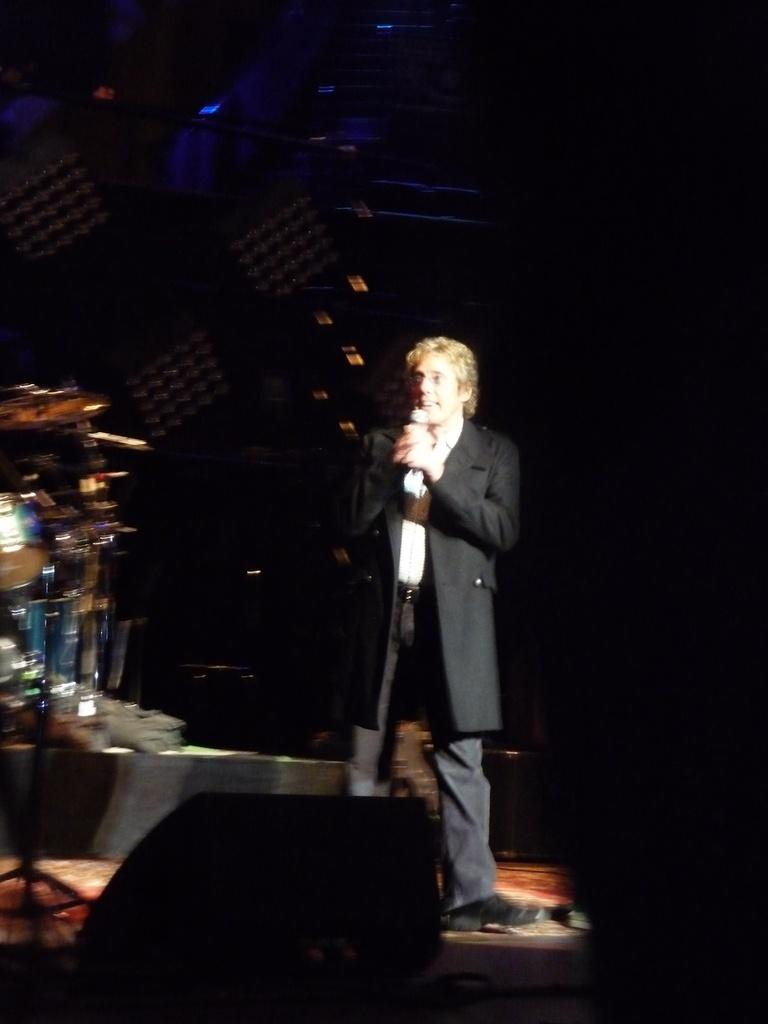What is the main feature of the image? There is a stage in the image. What is the person on the stage doing? One person is holding a microphone on the stage. What else can be seen on the stage? There are musical instruments on the left side of the stage. How would you describe the lighting in the image? The background of the image is dark. How many cars are parked in the quicksand behind the stage? There are no cars or quicksand present in the image; it only features a stage with a person holding a microphone and musical instruments. What type of spade is being used by the person on the stage? There is no spade visible in the image; the person is holding a microphone. 